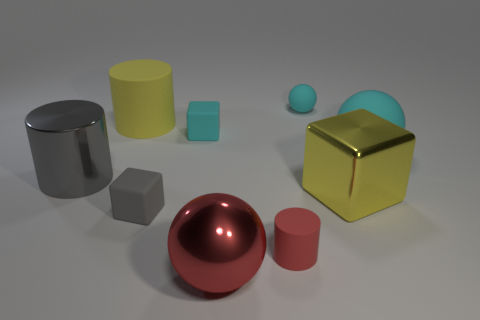Add 1 large brown matte cylinders. How many objects exist? 10 Subtract all cylinders. How many objects are left? 6 Subtract all tiny matte cubes. Subtract all red matte things. How many objects are left? 6 Add 4 large yellow metallic things. How many large yellow metallic things are left? 5 Add 5 metallic things. How many metallic things exist? 8 Subtract 0 purple cylinders. How many objects are left? 9 